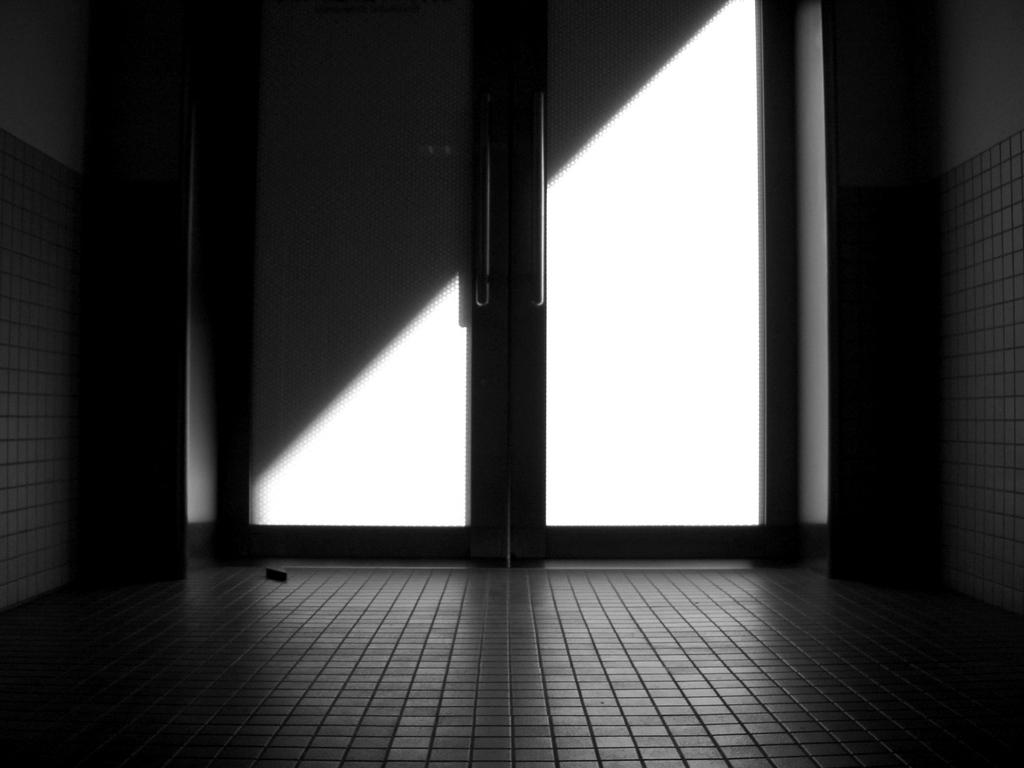What is the color scheme of the image? The image is black and white. What can be seen in the picture? There is a door in the picture. What surrounds the door? There are walls on either side of the door. What part of the room is visible at the bottom of the picture? The floor is visible at the bottom portion of the picture. What type of business is being conducted in the image? There is no indication of any business being conducted in the image, as it only features a door, walls, and a floor. Can you tell me the credit score of the person in the image? There is no person present in the image, so it is not possible to determine their credit score. 